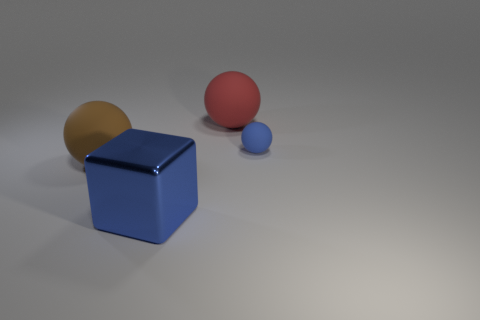Do the small matte thing and the blue shiny object have the same shape?
Your response must be concise. No. What is the shape of the brown rubber object?
Make the answer very short. Sphere. How many things have the same material as the big red sphere?
Your answer should be very brief. 2. Is the material of the big sphere on the right side of the big brown rubber thing the same as the cube?
Provide a succinct answer. No. Is there a purple cube?
Provide a short and direct response. No. There is a thing that is on the right side of the blue metal block and in front of the large red thing; how big is it?
Make the answer very short. Small. Is the number of blue matte balls behind the blue matte ball greater than the number of tiny matte balls left of the red object?
Ensure brevity in your answer.  No. There is a metal block that is the same color as the small object; what is its size?
Your answer should be compact. Large. The small matte object is what color?
Provide a succinct answer. Blue. What color is the thing that is both left of the red matte thing and to the right of the brown matte thing?
Make the answer very short. Blue. 